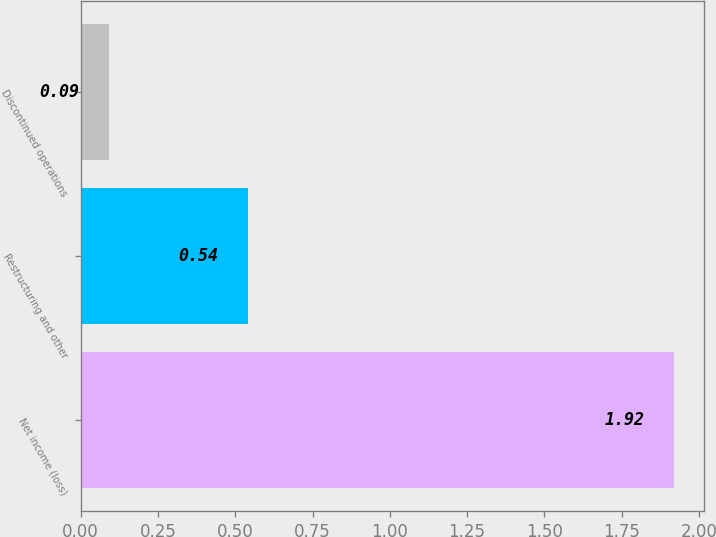Convert chart to OTSL. <chart><loc_0><loc_0><loc_500><loc_500><bar_chart><fcel>Net income (loss)<fcel>Restructuring and other<fcel>Discontinued operations<nl><fcel>1.92<fcel>0.54<fcel>0.09<nl></chart> 